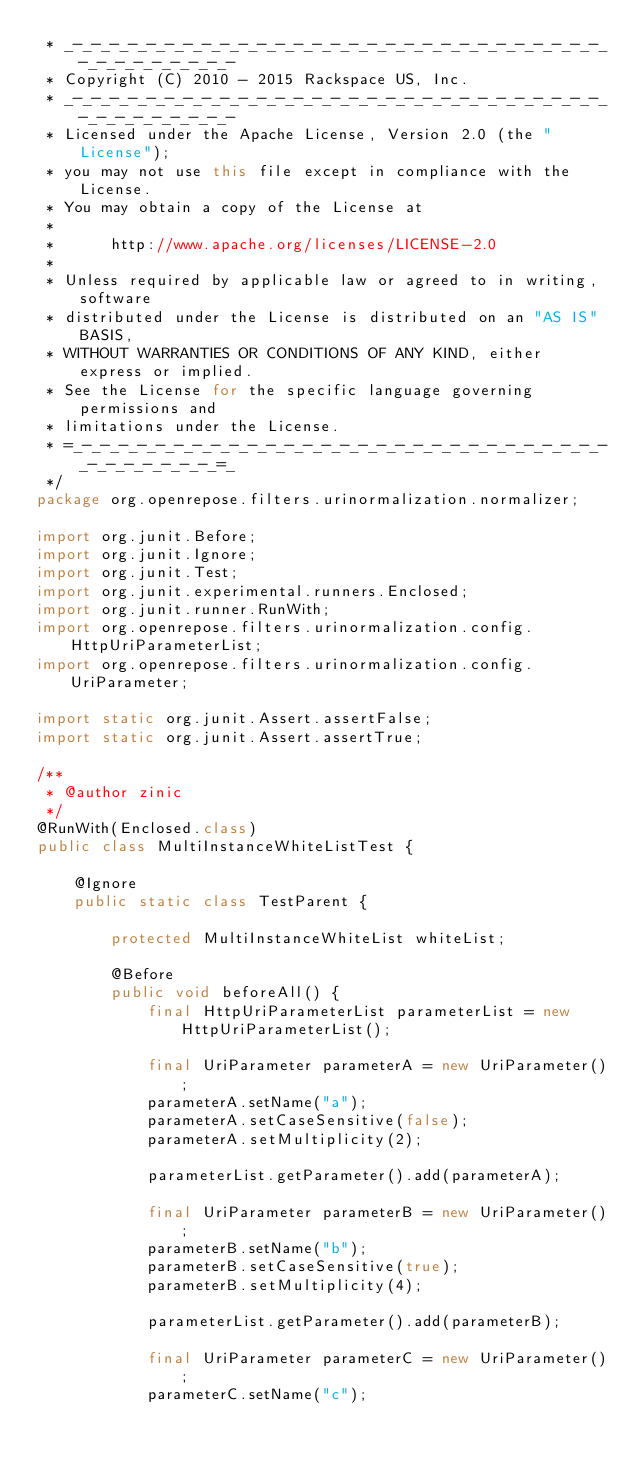<code> <loc_0><loc_0><loc_500><loc_500><_Java_> * _-_-_-_-_-_-_-_-_-_-_-_-_-_-_-_-_-_-_-_-_-_-_-_-_-_-_-_-_-_-_-_-_-_-_-_-_-_-
 * Copyright (C) 2010 - 2015 Rackspace US, Inc.
 * _-_-_-_-_-_-_-_-_-_-_-_-_-_-_-_-_-_-_-_-_-_-_-_-_-_-_-_-_-_-_-_-_-_-_-_-_-_-
 * Licensed under the Apache License, Version 2.0 (the "License");
 * you may not use this file except in compliance with the License.
 * You may obtain a copy of the License at
 * 
 *      http://www.apache.org/licenses/LICENSE-2.0
 * 
 * Unless required by applicable law or agreed to in writing, software
 * distributed under the License is distributed on an "AS IS" BASIS,
 * WITHOUT WARRANTIES OR CONDITIONS OF ANY KIND, either express or implied.
 * See the License for the specific language governing permissions and
 * limitations under the License.
 * =_-_-_-_-_-_-_-_-_-_-_-_-_-_-_-_-_-_-_-_-_-_-_-_-_-_-_-_-_-_-_-_-_-_-_-_-_=_
 */
package org.openrepose.filters.urinormalization.normalizer;

import org.junit.Before;
import org.junit.Ignore;
import org.junit.Test;
import org.junit.experimental.runners.Enclosed;
import org.junit.runner.RunWith;
import org.openrepose.filters.urinormalization.config.HttpUriParameterList;
import org.openrepose.filters.urinormalization.config.UriParameter;

import static org.junit.Assert.assertFalse;
import static org.junit.Assert.assertTrue;

/**
 * @author zinic
 */
@RunWith(Enclosed.class)
public class MultiInstanceWhiteListTest {

    @Ignore
    public static class TestParent {

        protected MultiInstanceWhiteList whiteList;

        @Before
        public void beforeAll() {
            final HttpUriParameterList parameterList = new HttpUriParameterList();

            final UriParameter parameterA = new UriParameter();
            parameterA.setName("a");
            parameterA.setCaseSensitive(false);
            parameterA.setMultiplicity(2);

            parameterList.getParameter().add(parameterA);

            final UriParameter parameterB = new UriParameter();
            parameterB.setName("b");
            parameterB.setCaseSensitive(true);
            parameterB.setMultiplicity(4);

            parameterList.getParameter().add(parameterB);

            final UriParameter parameterC = new UriParameter();
            parameterC.setName("c");</code> 